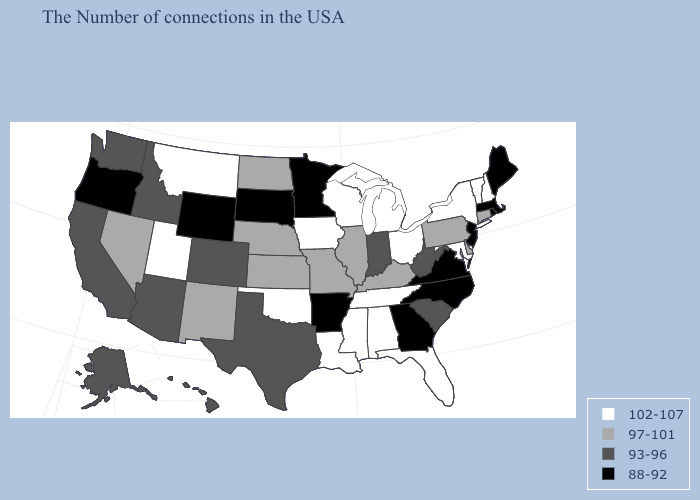What is the value of Montana?
Answer briefly. 102-107. Name the states that have a value in the range 102-107?
Give a very brief answer. New Hampshire, Vermont, New York, Maryland, Ohio, Florida, Michigan, Alabama, Tennessee, Wisconsin, Mississippi, Louisiana, Iowa, Oklahoma, Utah, Montana. Which states hav the highest value in the Northeast?
Give a very brief answer. New Hampshire, Vermont, New York. Which states hav the highest value in the Northeast?
Keep it brief. New Hampshire, Vermont, New York. Does Alaska have a higher value than South Dakota?
Short answer required. Yes. What is the highest value in states that border Connecticut?
Short answer required. 102-107. What is the value of Kansas?
Be succinct. 97-101. Does the first symbol in the legend represent the smallest category?
Short answer required. No. What is the lowest value in the USA?
Write a very short answer. 88-92. Does New Jersey have the lowest value in the Northeast?
Keep it brief. Yes. Which states hav the highest value in the South?
Keep it brief. Maryland, Florida, Alabama, Tennessee, Mississippi, Louisiana, Oklahoma. Among the states that border New Jersey , does Delaware have the highest value?
Concise answer only. No. Name the states that have a value in the range 102-107?
Answer briefly. New Hampshire, Vermont, New York, Maryland, Ohio, Florida, Michigan, Alabama, Tennessee, Wisconsin, Mississippi, Louisiana, Iowa, Oklahoma, Utah, Montana. Does Missouri have the highest value in the USA?
Keep it brief. No. What is the highest value in the South ?
Answer briefly. 102-107. 